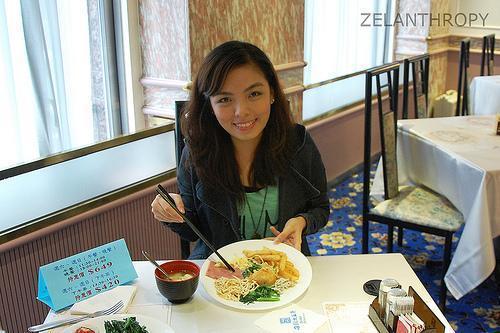How many people are in the picture?
Give a very brief answer. 1. 